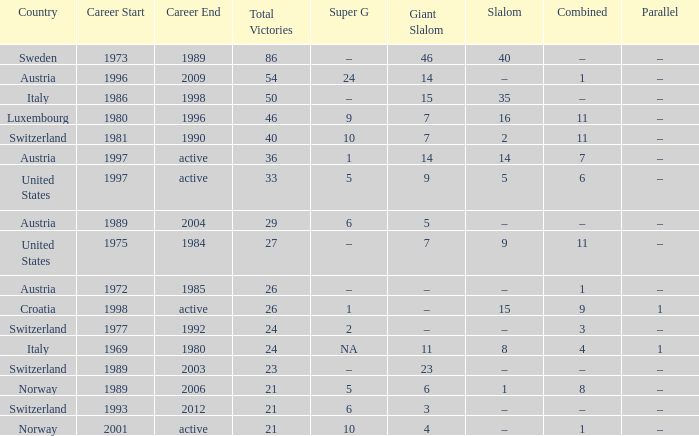What Country has a Career of 1989–2004? Austria. 